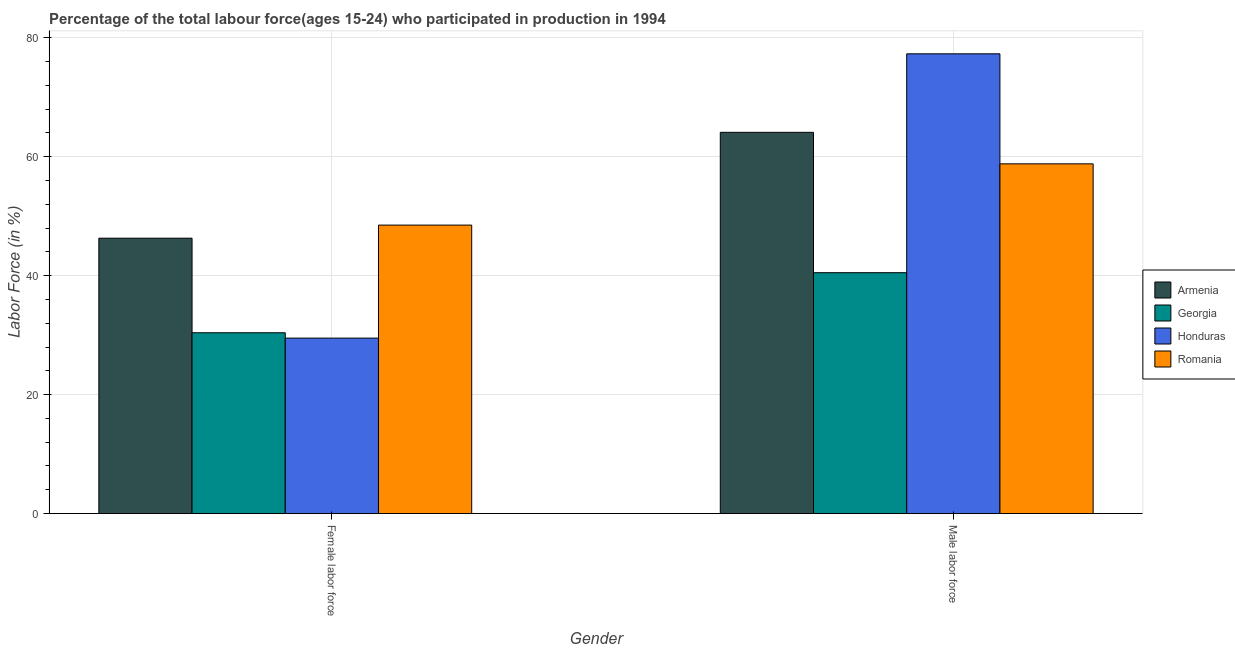How many different coloured bars are there?
Ensure brevity in your answer.  4. Are the number of bars per tick equal to the number of legend labels?
Provide a succinct answer. Yes. Are the number of bars on each tick of the X-axis equal?
Your answer should be compact. Yes. How many bars are there on the 2nd tick from the right?
Provide a succinct answer. 4. What is the label of the 2nd group of bars from the left?
Offer a terse response. Male labor force. What is the percentage of male labour force in Georgia?
Your answer should be very brief. 40.5. Across all countries, what is the maximum percentage of female labor force?
Ensure brevity in your answer.  48.5. Across all countries, what is the minimum percentage of female labor force?
Offer a very short reply. 29.5. In which country was the percentage of female labor force maximum?
Provide a short and direct response. Romania. In which country was the percentage of female labor force minimum?
Ensure brevity in your answer.  Honduras. What is the total percentage of male labour force in the graph?
Make the answer very short. 240.7. What is the difference between the percentage of male labour force in Honduras and that in Georgia?
Provide a short and direct response. 36.8. What is the average percentage of female labor force per country?
Your response must be concise. 38.67. What is the difference between the percentage of female labor force and percentage of male labour force in Honduras?
Your response must be concise. -47.8. In how many countries, is the percentage of male labour force greater than 76 %?
Offer a terse response. 1. What is the ratio of the percentage of female labor force in Honduras to that in Armenia?
Make the answer very short. 0.64. Is the percentage of female labor force in Romania less than that in Armenia?
Your answer should be compact. No. What does the 1st bar from the left in Male labor force represents?
Offer a very short reply. Armenia. What does the 1st bar from the right in Male labor force represents?
Your response must be concise. Romania. How many bars are there?
Keep it short and to the point. 8. Are all the bars in the graph horizontal?
Ensure brevity in your answer.  No. What is the difference between two consecutive major ticks on the Y-axis?
Provide a short and direct response. 20. Are the values on the major ticks of Y-axis written in scientific E-notation?
Provide a succinct answer. No. Does the graph contain any zero values?
Offer a very short reply. No. Where does the legend appear in the graph?
Keep it short and to the point. Center right. How are the legend labels stacked?
Give a very brief answer. Vertical. What is the title of the graph?
Provide a succinct answer. Percentage of the total labour force(ages 15-24) who participated in production in 1994. Does "Mexico" appear as one of the legend labels in the graph?
Your response must be concise. No. What is the label or title of the X-axis?
Provide a succinct answer. Gender. What is the label or title of the Y-axis?
Provide a succinct answer. Labor Force (in %). What is the Labor Force (in %) in Armenia in Female labor force?
Ensure brevity in your answer.  46.3. What is the Labor Force (in %) in Georgia in Female labor force?
Offer a terse response. 30.4. What is the Labor Force (in %) of Honduras in Female labor force?
Give a very brief answer. 29.5. What is the Labor Force (in %) in Romania in Female labor force?
Provide a short and direct response. 48.5. What is the Labor Force (in %) of Armenia in Male labor force?
Ensure brevity in your answer.  64.1. What is the Labor Force (in %) in Georgia in Male labor force?
Offer a terse response. 40.5. What is the Labor Force (in %) of Honduras in Male labor force?
Provide a short and direct response. 77.3. What is the Labor Force (in %) of Romania in Male labor force?
Provide a short and direct response. 58.8. Across all Gender, what is the maximum Labor Force (in %) of Armenia?
Offer a terse response. 64.1. Across all Gender, what is the maximum Labor Force (in %) in Georgia?
Make the answer very short. 40.5. Across all Gender, what is the maximum Labor Force (in %) of Honduras?
Provide a short and direct response. 77.3. Across all Gender, what is the maximum Labor Force (in %) of Romania?
Provide a short and direct response. 58.8. Across all Gender, what is the minimum Labor Force (in %) in Armenia?
Ensure brevity in your answer.  46.3. Across all Gender, what is the minimum Labor Force (in %) in Georgia?
Your answer should be very brief. 30.4. Across all Gender, what is the minimum Labor Force (in %) of Honduras?
Provide a succinct answer. 29.5. Across all Gender, what is the minimum Labor Force (in %) in Romania?
Keep it short and to the point. 48.5. What is the total Labor Force (in %) of Armenia in the graph?
Provide a short and direct response. 110.4. What is the total Labor Force (in %) in Georgia in the graph?
Your response must be concise. 70.9. What is the total Labor Force (in %) of Honduras in the graph?
Your response must be concise. 106.8. What is the total Labor Force (in %) of Romania in the graph?
Give a very brief answer. 107.3. What is the difference between the Labor Force (in %) of Armenia in Female labor force and that in Male labor force?
Keep it short and to the point. -17.8. What is the difference between the Labor Force (in %) in Honduras in Female labor force and that in Male labor force?
Your response must be concise. -47.8. What is the difference between the Labor Force (in %) in Armenia in Female labor force and the Labor Force (in %) in Georgia in Male labor force?
Offer a very short reply. 5.8. What is the difference between the Labor Force (in %) of Armenia in Female labor force and the Labor Force (in %) of Honduras in Male labor force?
Provide a short and direct response. -31. What is the difference between the Labor Force (in %) of Armenia in Female labor force and the Labor Force (in %) of Romania in Male labor force?
Offer a very short reply. -12.5. What is the difference between the Labor Force (in %) of Georgia in Female labor force and the Labor Force (in %) of Honduras in Male labor force?
Provide a succinct answer. -46.9. What is the difference between the Labor Force (in %) in Georgia in Female labor force and the Labor Force (in %) in Romania in Male labor force?
Provide a short and direct response. -28.4. What is the difference between the Labor Force (in %) in Honduras in Female labor force and the Labor Force (in %) in Romania in Male labor force?
Provide a short and direct response. -29.3. What is the average Labor Force (in %) in Armenia per Gender?
Provide a short and direct response. 55.2. What is the average Labor Force (in %) in Georgia per Gender?
Offer a terse response. 35.45. What is the average Labor Force (in %) of Honduras per Gender?
Make the answer very short. 53.4. What is the average Labor Force (in %) of Romania per Gender?
Provide a short and direct response. 53.65. What is the difference between the Labor Force (in %) of Armenia and Labor Force (in %) of Honduras in Female labor force?
Provide a short and direct response. 16.8. What is the difference between the Labor Force (in %) of Georgia and Labor Force (in %) of Romania in Female labor force?
Provide a succinct answer. -18.1. What is the difference between the Labor Force (in %) of Armenia and Labor Force (in %) of Georgia in Male labor force?
Provide a short and direct response. 23.6. What is the difference between the Labor Force (in %) in Armenia and Labor Force (in %) in Honduras in Male labor force?
Your response must be concise. -13.2. What is the difference between the Labor Force (in %) in Armenia and Labor Force (in %) in Romania in Male labor force?
Offer a very short reply. 5.3. What is the difference between the Labor Force (in %) in Georgia and Labor Force (in %) in Honduras in Male labor force?
Provide a succinct answer. -36.8. What is the difference between the Labor Force (in %) in Georgia and Labor Force (in %) in Romania in Male labor force?
Offer a terse response. -18.3. What is the ratio of the Labor Force (in %) in Armenia in Female labor force to that in Male labor force?
Provide a short and direct response. 0.72. What is the ratio of the Labor Force (in %) of Georgia in Female labor force to that in Male labor force?
Offer a very short reply. 0.75. What is the ratio of the Labor Force (in %) of Honduras in Female labor force to that in Male labor force?
Offer a very short reply. 0.38. What is the ratio of the Labor Force (in %) in Romania in Female labor force to that in Male labor force?
Provide a short and direct response. 0.82. What is the difference between the highest and the second highest Labor Force (in %) of Georgia?
Provide a short and direct response. 10.1. What is the difference between the highest and the second highest Labor Force (in %) in Honduras?
Your answer should be very brief. 47.8. What is the difference between the highest and the second highest Labor Force (in %) in Romania?
Give a very brief answer. 10.3. What is the difference between the highest and the lowest Labor Force (in %) of Armenia?
Give a very brief answer. 17.8. What is the difference between the highest and the lowest Labor Force (in %) of Georgia?
Your answer should be very brief. 10.1. What is the difference between the highest and the lowest Labor Force (in %) in Honduras?
Make the answer very short. 47.8. What is the difference between the highest and the lowest Labor Force (in %) in Romania?
Ensure brevity in your answer.  10.3. 